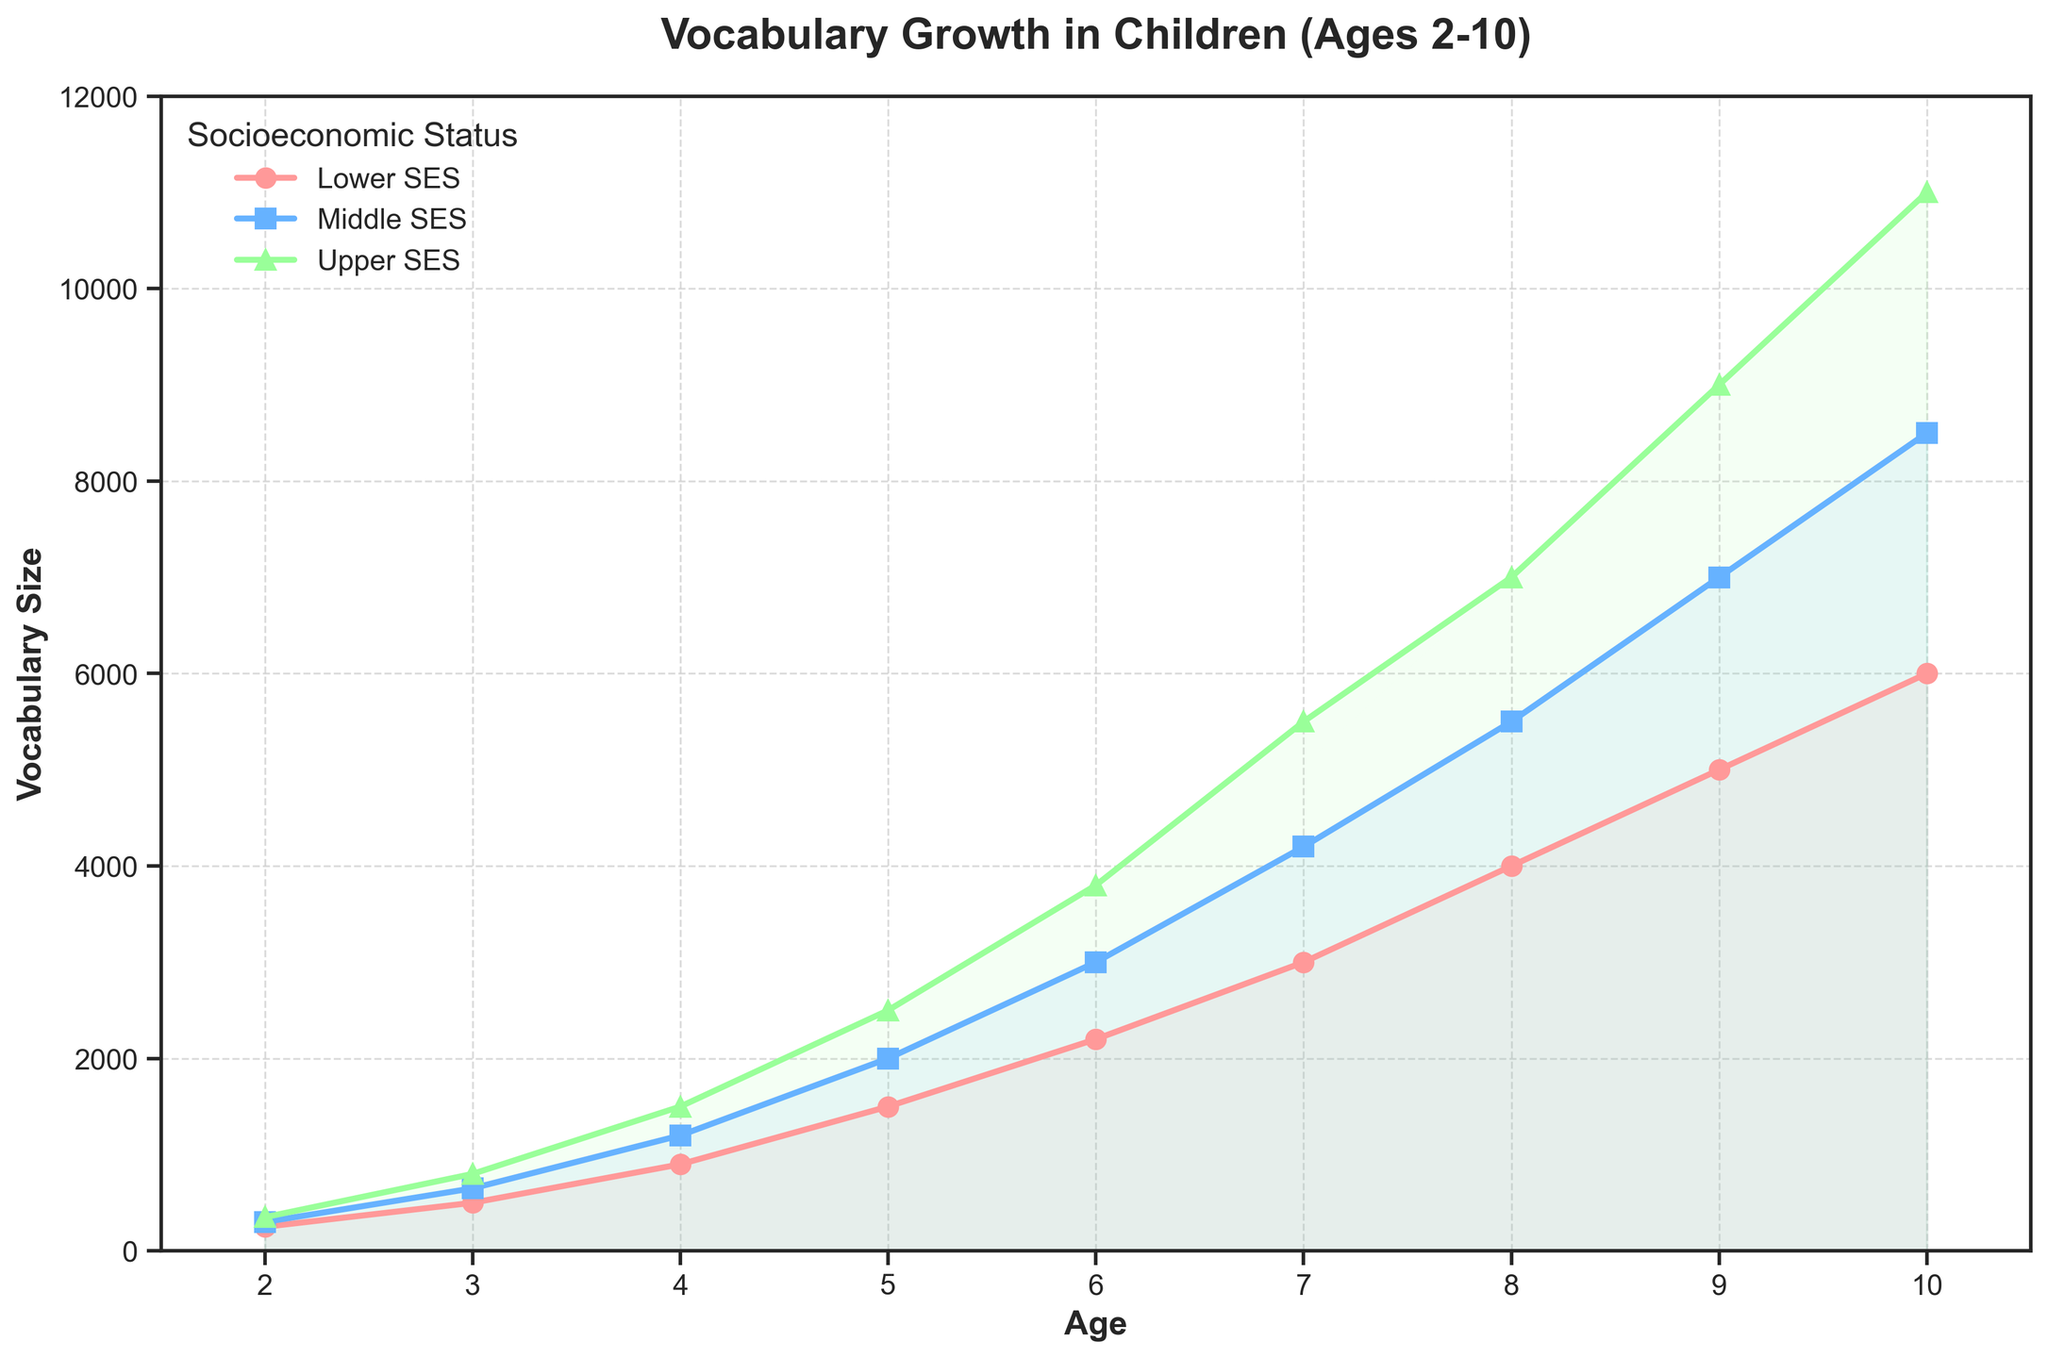When does the vocabulary size for children in the Lower SES reach 3000 words? The x-axis represents age, and the y-axis represents vocabulary size. Locate when the Lower SES line first touches or exceeds the 3000 mark on the y-axis.
Answer: Age 7 At age 5, which SES group has the largest vocabulary size and how much is it? Look at the y-values for all SES groups at Age 5 in the chart. Identify the highest value.
Answer: Upper SES, 2500 words What is the vocabulary difference between Lower SES and Upper SES at age 4? Find the vocabulary sizes for Lower SES and Upper SES at age 4. Calculate the difference between them: 1500 (Upper) - 900 (Lower).
Answer: 600 words How much does the vocabulary size increase for Middle SES children from ages 6 to 8? Find the vocabulary sizes for Middle SES at ages 6 and 8. Calculate the difference: 5500 (age 8) - 3000 (age 6).
Answer: 2500 words Which age range shows the most rapid vocabulary growth for Upper SES children? Look for the steepest section in the Upper SES line by comparing the slopes between various age ranges. The slope from age 2 to 3, or from 9 to 10, is the steepest.
Answer: Age 2 to 3 or Age 9 to 10 At what age do Middle SES children surpass 5000 words in their vocabulary size? Look at the point where the Middle SES line first crosses the 5000 mark on the y-axis.
Answer: Age 8 How much larger is the vocabulary size of Upper SES children compared to Lower SES children at age 10? Find the vocabulary sizes for both Upper SES and Lower SES at age 10. Calculate the difference: 11000 (Upper) - 6000 (Lower).
Answer: 5000 words Does the average vocabulary size increase more rapidly between ages 2-5 or 6-9 across all SES groups? Calculate the average vocabulary increase for both age ranges: (Average of vocab sizes at ages 2-5) and (Average of vocab sizes at ages 6-9), and compare the rate of increase.
Answer: Ages 6-9 Between ages 7 and 8, which SES group has the smallest vocabulary growth, and how much is it? Identify the growth for each SES group by calculating the differences: Lower SES (1000), Middle SES (1300), Upper SES (1500).
Answer: Lower SES, 1000 words 